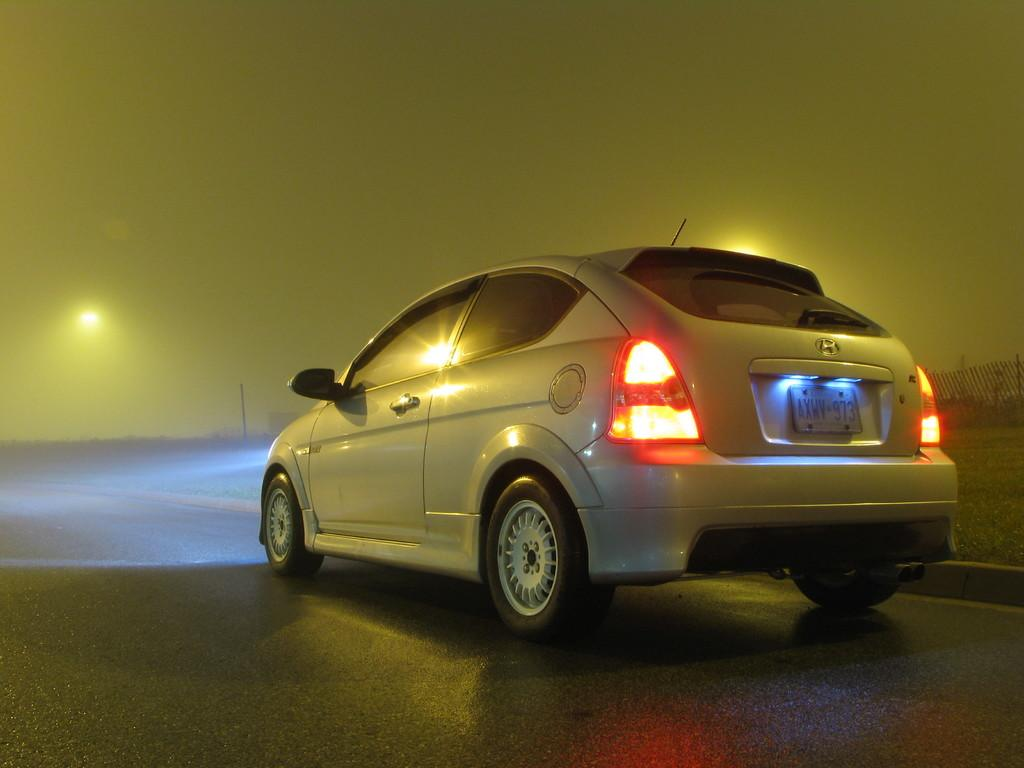Provide a one-sentence caption for the provided image. A Honda car from the province of Ontario. 